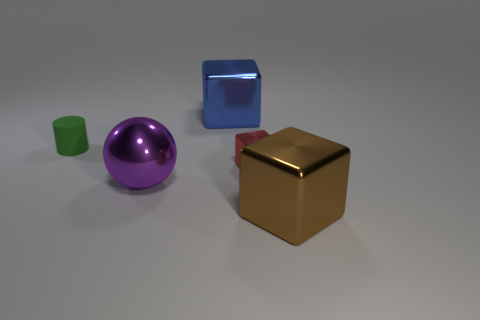What material is the big cube that is behind the large thing that is to the right of the big thing that is behind the big purple sphere?
Your response must be concise. Metal. Are the large cube behind the brown block and the tiny object in front of the small matte cylinder made of the same material?
Ensure brevity in your answer.  Yes. How big is the thing that is both to the left of the red metal thing and right of the big metal ball?
Offer a very short reply. Large. What material is the red block that is the same size as the green matte thing?
Offer a terse response. Metal. What number of large metal things are on the right side of the large object that is right of the large metallic cube on the left side of the big brown shiny thing?
Offer a terse response. 0. There is a big thing behind the big shiny sphere; is it the same color as the small object right of the tiny green cylinder?
Make the answer very short. No. What color is the metallic thing that is in front of the blue metallic object and to the left of the red object?
Provide a short and direct response. Purple. What number of other green matte cylinders are the same size as the matte cylinder?
Ensure brevity in your answer.  0. There is a big shiny object that is left of the large object that is behind the small block; what is its shape?
Provide a succinct answer. Sphere. The small thing that is right of the large cube that is left of the metal block right of the small red shiny object is what shape?
Offer a very short reply. Cube. 